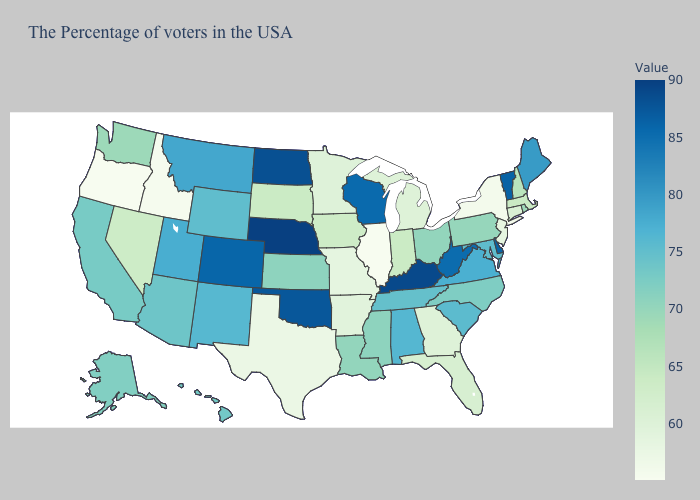Among the states that border Illinois , does Iowa have the lowest value?
Be succinct. No. Among the states that border Missouri , does Tennessee have the highest value?
Answer briefly. No. 